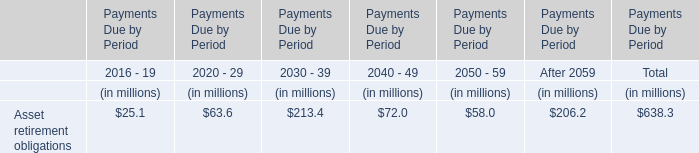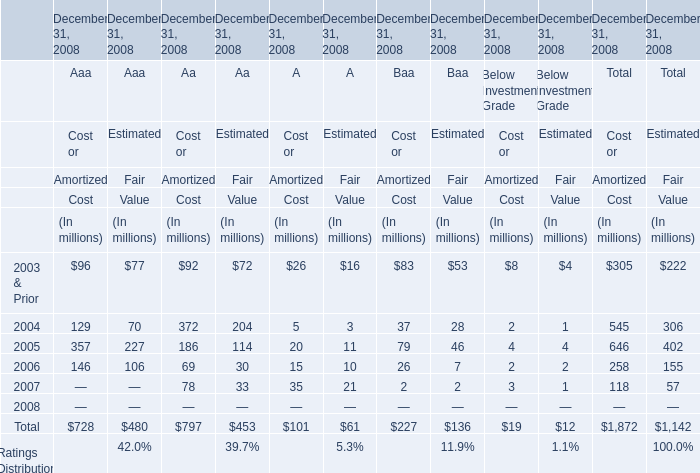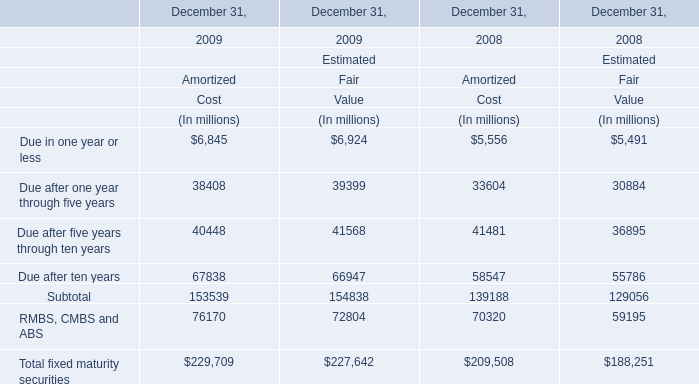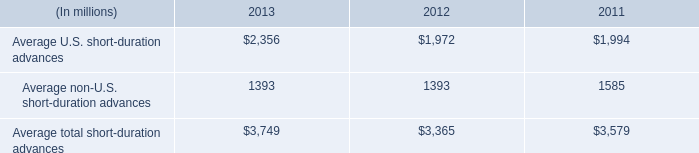what percent has short duration advances in the us increased between 2011 and 2013? 
Computations: ((2356 - 1994) / 1994)
Answer: 0.18154. 